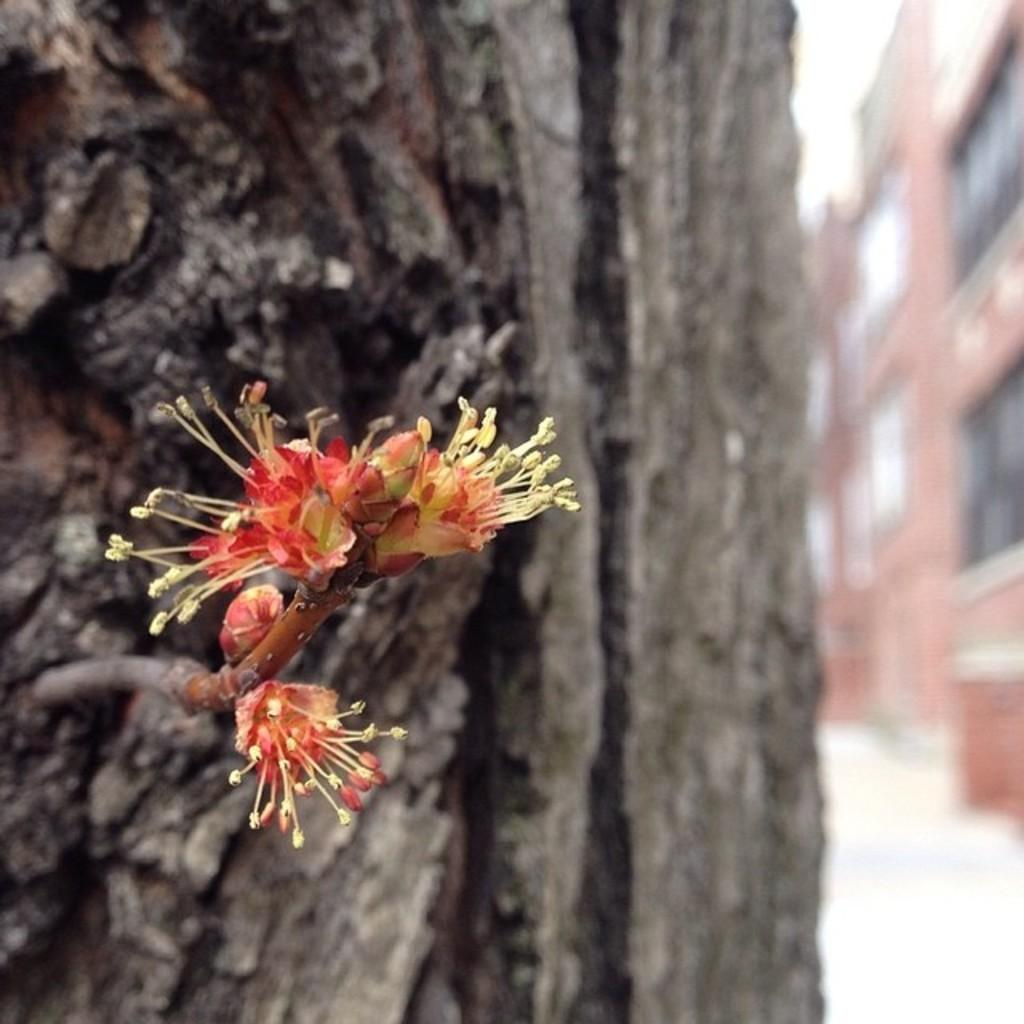What type of vegetation can be seen on the tree in the image? There are flowers on the tree in the image. What structure is located on the right side of the image? There is a building on the right side of the image. How many bikes are parked on the ground in the image? There are no bikes present in the image. What type of thread is used to connect the flowers on the tree? There is no thread connecting the flowers on the tree in the image; they are naturally growing on the tree. 